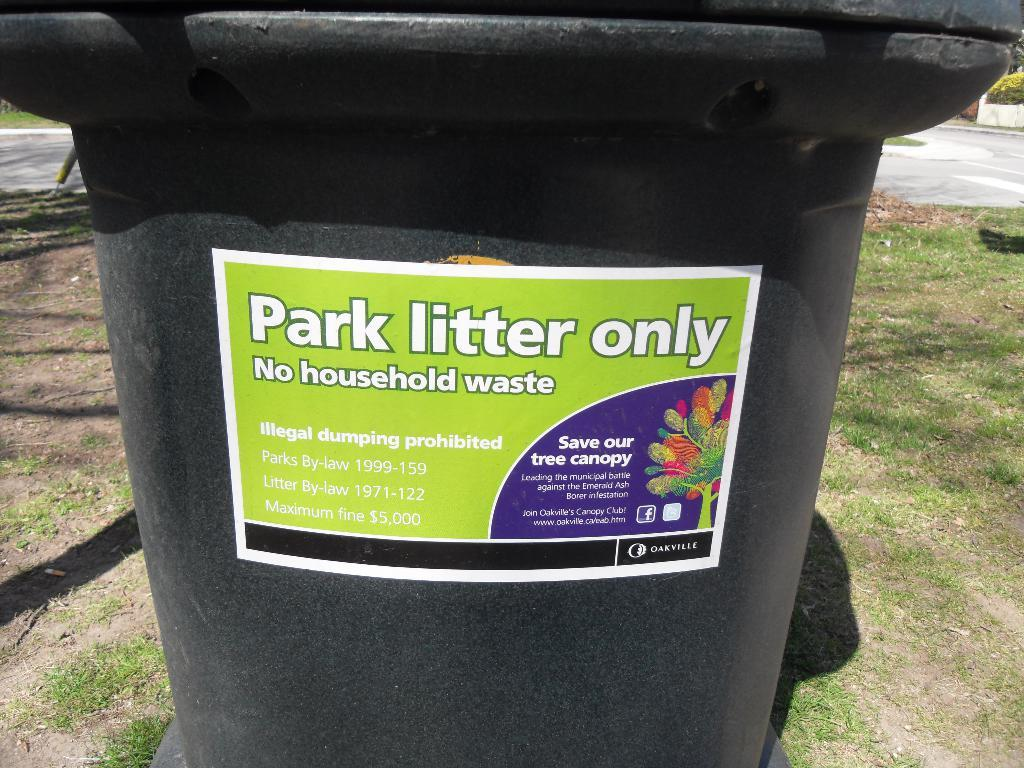<image>
Give a short and clear explanation of the subsequent image. Black dumpster with a green label that says "Park Litter Only". 